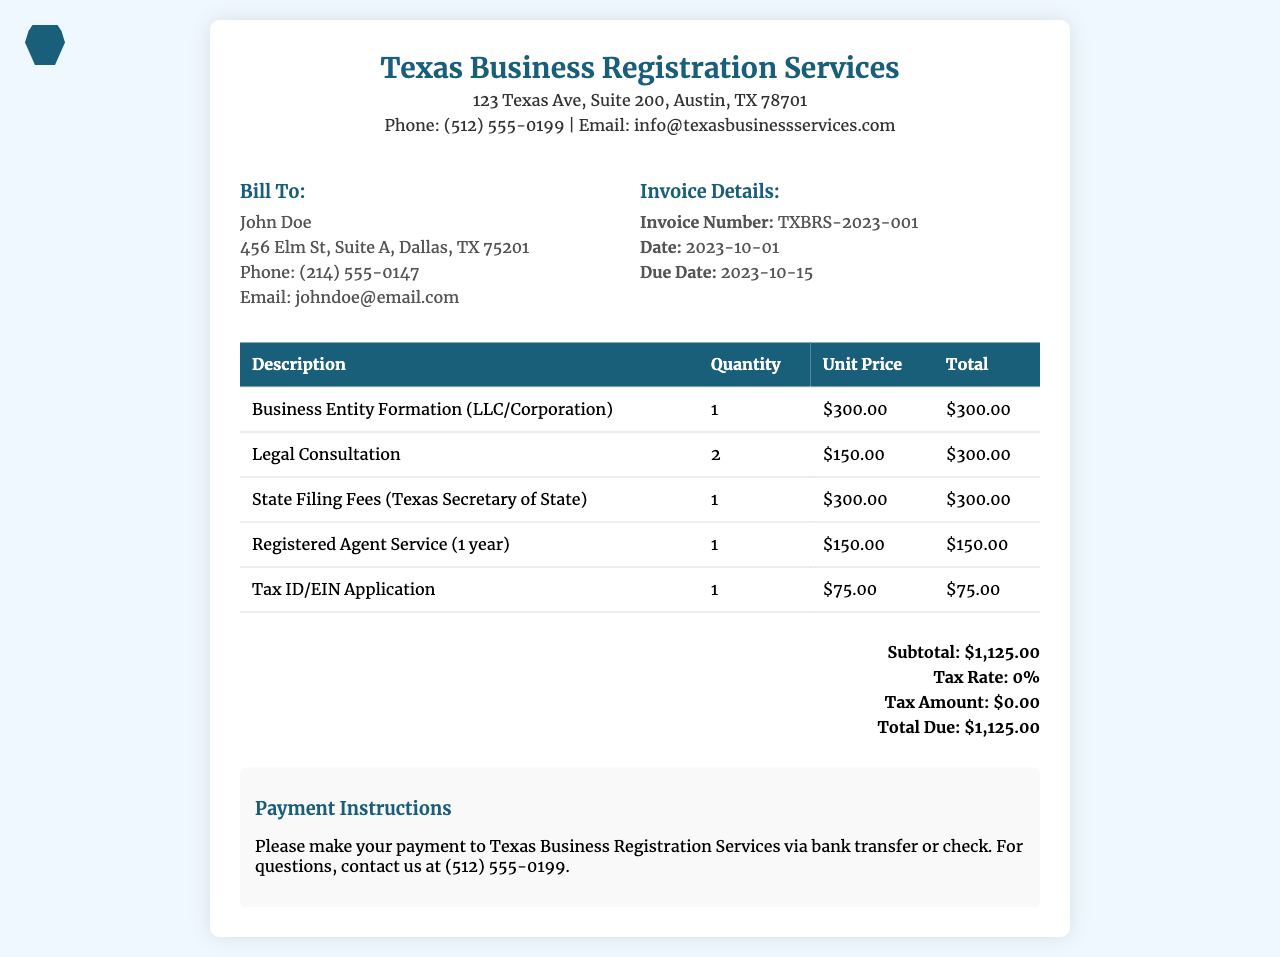What is the invoice number? The invoice number is mentioned in the "Invoice Details" section of the document.
Answer: TXBRS-2023-001 What is the due date for this invoice? The due date is provided in the "Invoice Details" section of the document.
Answer: 2023-10-15 How much is charged for Legal Consultation? The Legal Consultation charge appears in the table listing services and their costs.
Answer: $300.00 What is the total due amount? The total due is calculated at the bottom of the invoice summary.
Answer: $1,125.00 How many legal consultations are included in the invoice? The quantity of legal consultations is shown in the services table.
Answer: 2 What service has a filing fee associated with it? The relevant service with a filing fee is clearly stated in the description column of the table.
Answer: State Filing Fees (Texas Secretary of State) What is the subtotal before tax? The subtotal is clearly listed in the summary section right before tax calculations.
Answer: $1,125.00 Who is the billed party? The billed party information is located under the "Bill To" section.
Answer: John Doe What service requires a Registered Agent? The service that includes a Registered Agent can be identified in the services table.
Answer: Registered Agent Service (1 year) 